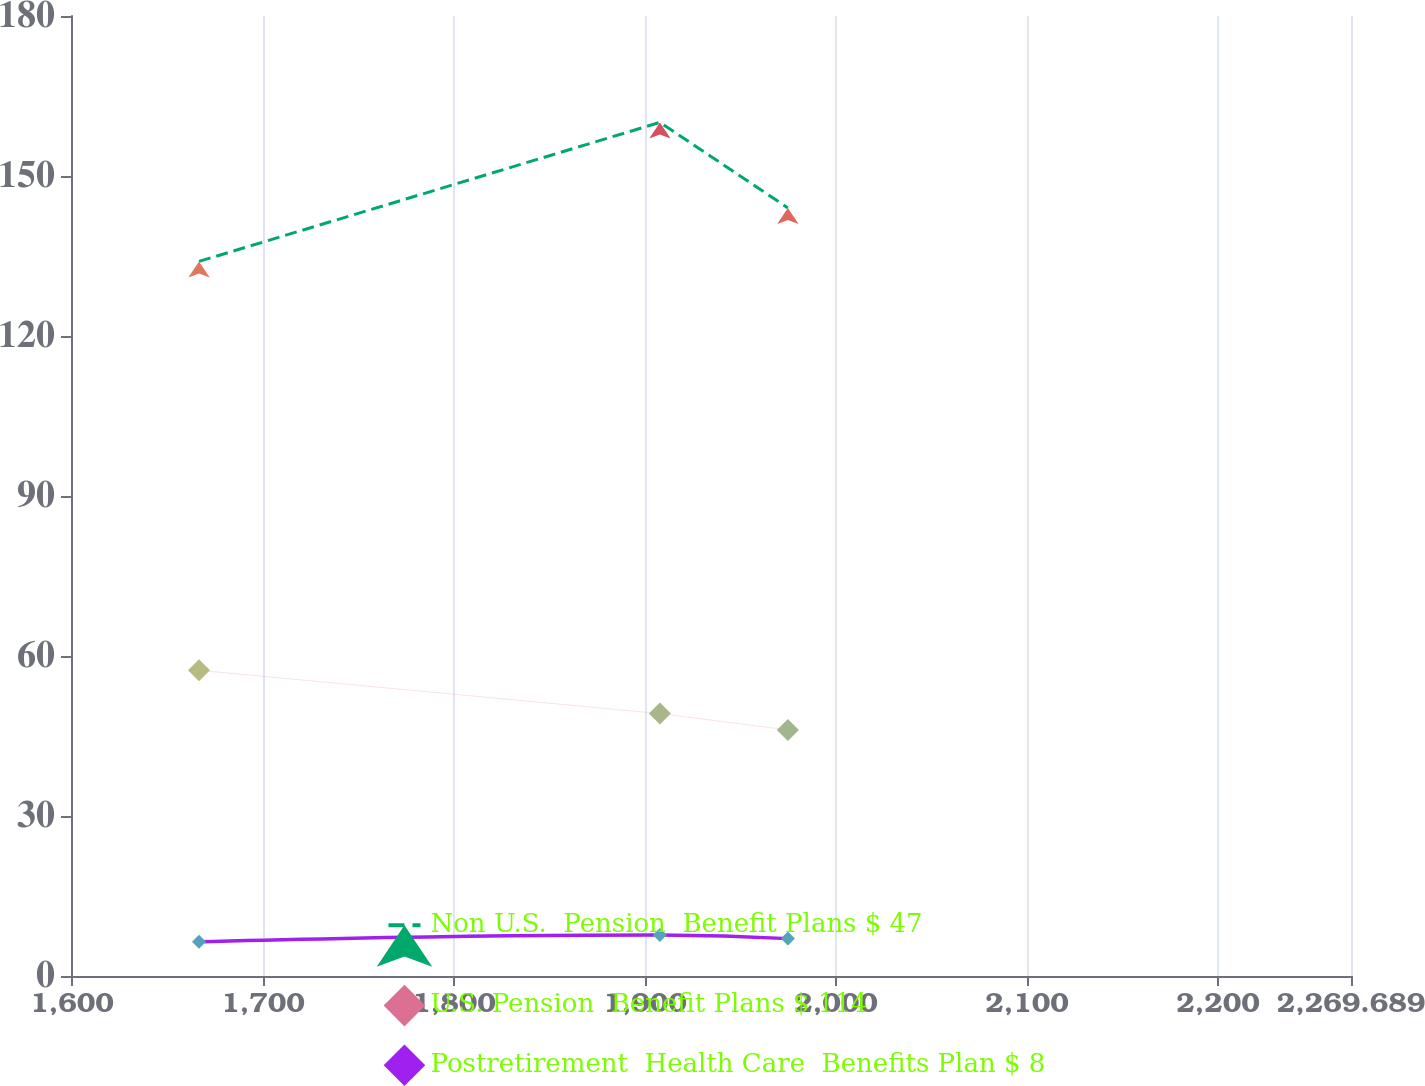Convert chart to OTSL. <chart><loc_0><loc_0><loc_500><loc_500><line_chart><ecel><fcel>Non U.S.  Pension  Benefit Plans $ 47<fcel>U.S. Pension  Benefit Plans $ 114<fcel>Postretirement  Health Care  Benefits Plan $ 8<nl><fcel>1666.5<fcel>133.99<fcel>57.31<fcel>6.41<nl><fcel>1907.83<fcel>160.05<fcel>49.2<fcel>7.68<nl><fcel>1974.85<fcel>144.02<fcel>46.14<fcel>7.01<nl><fcel>2336.71<fcel>157.52<fcel>48.08<fcel>5.4<nl></chart> 